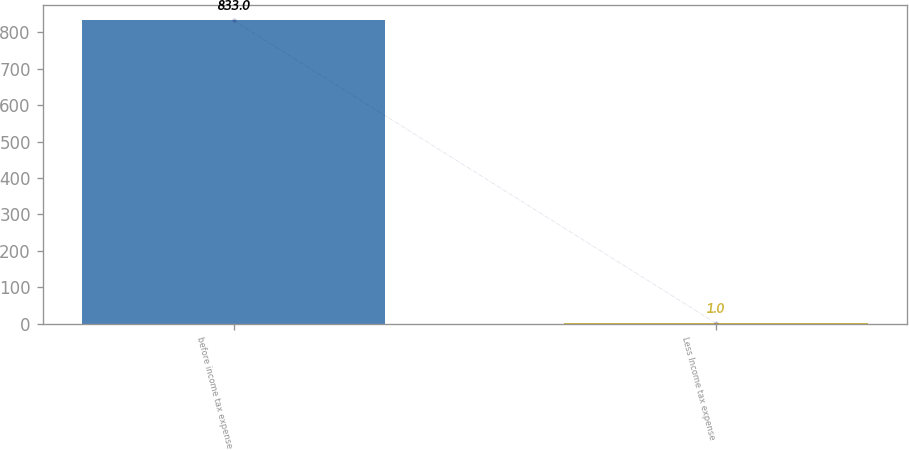<chart> <loc_0><loc_0><loc_500><loc_500><bar_chart><fcel>before income tax expense<fcel>Less Income tax expense<nl><fcel>833<fcel>1<nl></chart> 